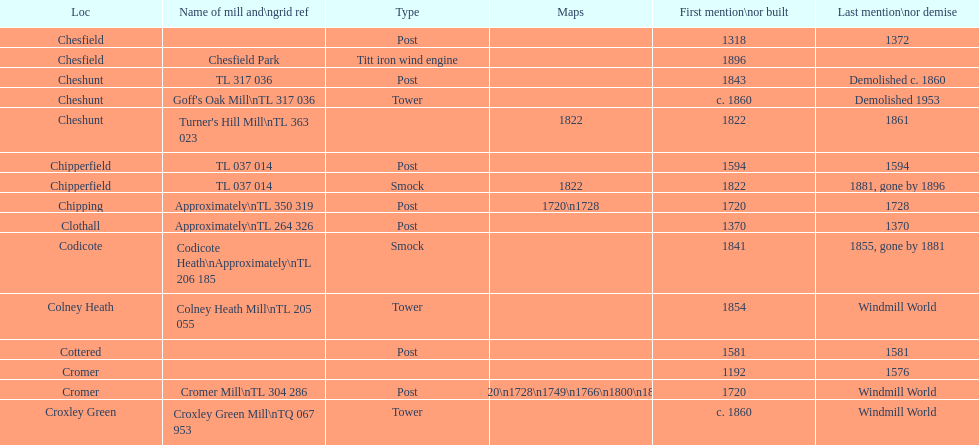How many locations have or had at least 2 windmills? 4. 